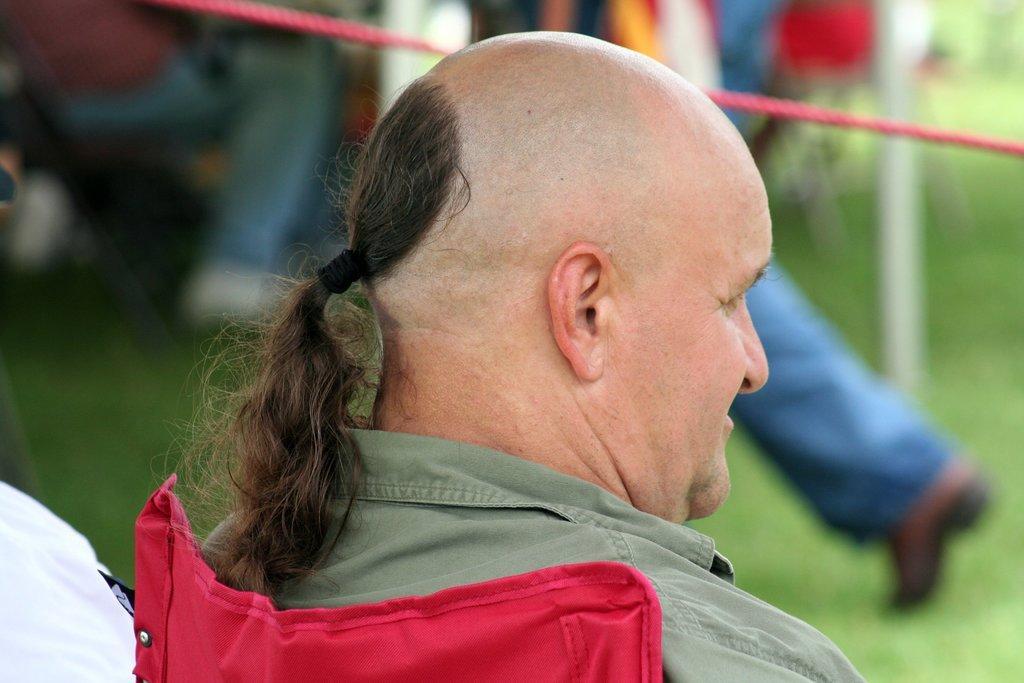In one or two sentences, can you explain what this image depicts? In this image we can see a person with long hair is sitting in a chair. In the background we can see a person standing in the ground and a person sitting. 